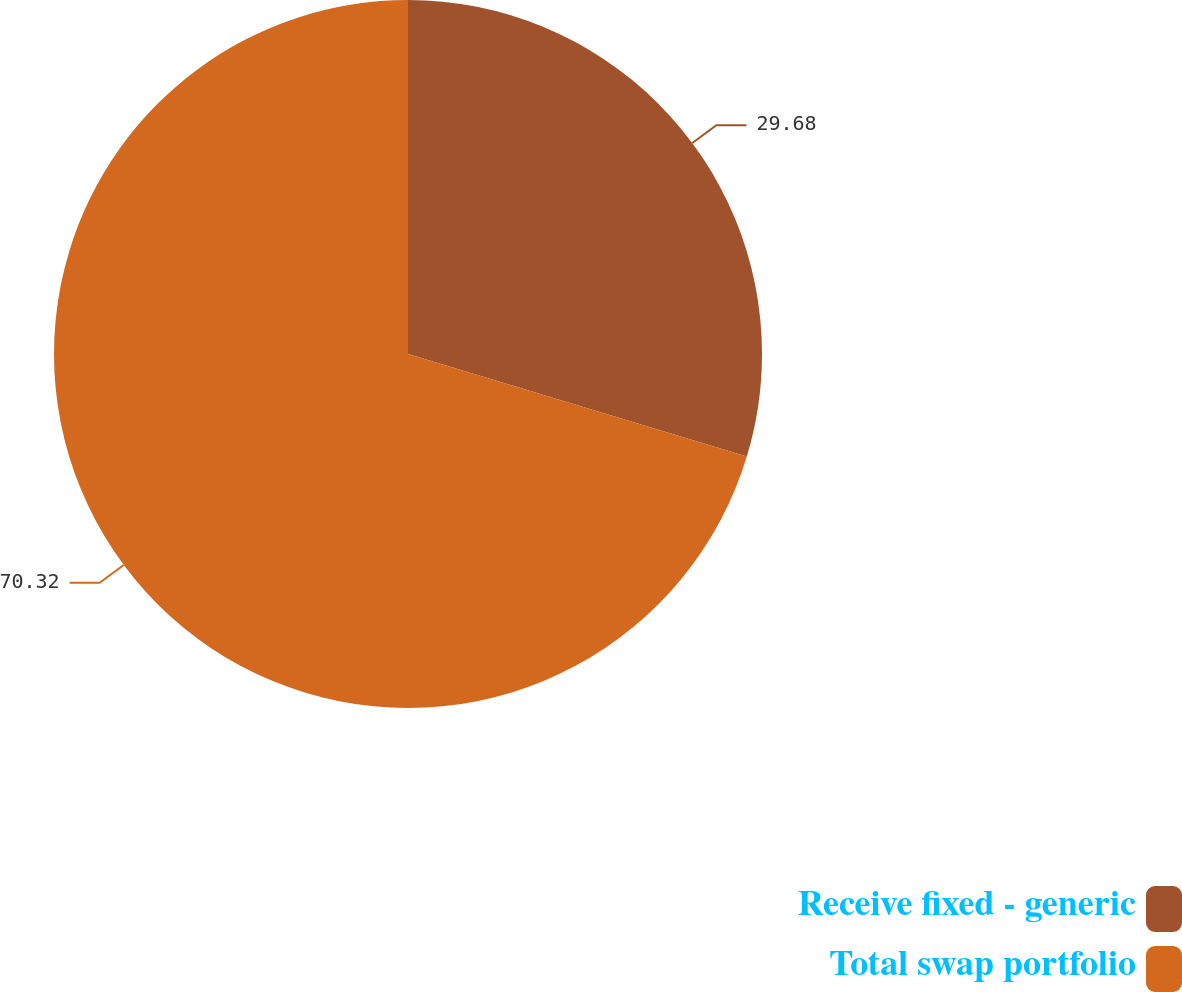Convert chart to OTSL. <chart><loc_0><loc_0><loc_500><loc_500><pie_chart><fcel>Receive fixed - generic<fcel>Total swap portfolio<nl><fcel>29.68%<fcel>70.32%<nl></chart> 